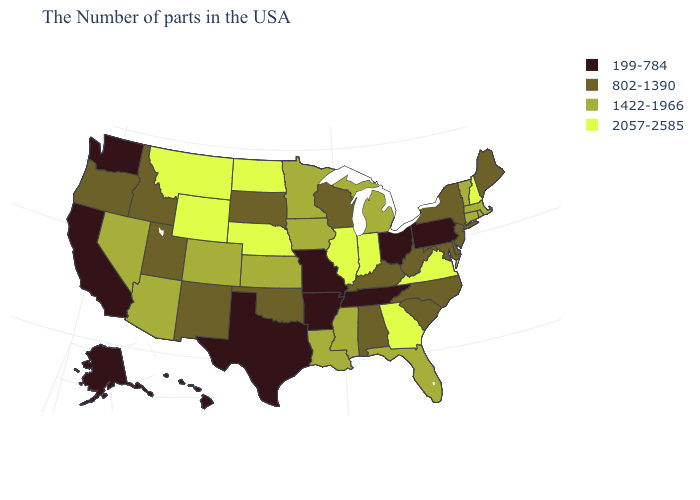Among the states that border North Dakota , which have the highest value?
Answer briefly. Montana. What is the lowest value in the West?
Answer briefly. 199-784. Does the first symbol in the legend represent the smallest category?
Keep it brief. Yes. What is the highest value in states that border Illinois?
Concise answer only. 2057-2585. Name the states that have a value in the range 802-1390?
Give a very brief answer. Maine, New York, New Jersey, Delaware, Maryland, North Carolina, South Carolina, West Virginia, Kentucky, Alabama, Wisconsin, Oklahoma, South Dakota, New Mexico, Utah, Idaho, Oregon. What is the value of New York?
Write a very short answer. 802-1390. Does the map have missing data?
Quick response, please. No. What is the highest value in states that border New Hampshire?
Give a very brief answer. 1422-1966. How many symbols are there in the legend?
Quick response, please. 4. What is the lowest value in the USA?
Give a very brief answer. 199-784. What is the value of Maine?
Give a very brief answer. 802-1390. What is the value of New Jersey?
Keep it brief. 802-1390. Is the legend a continuous bar?
Keep it brief. No. Does Florida have a lower value than Washington?
Be succinct. No. Does the map have missing data?
Short answer required. No. 